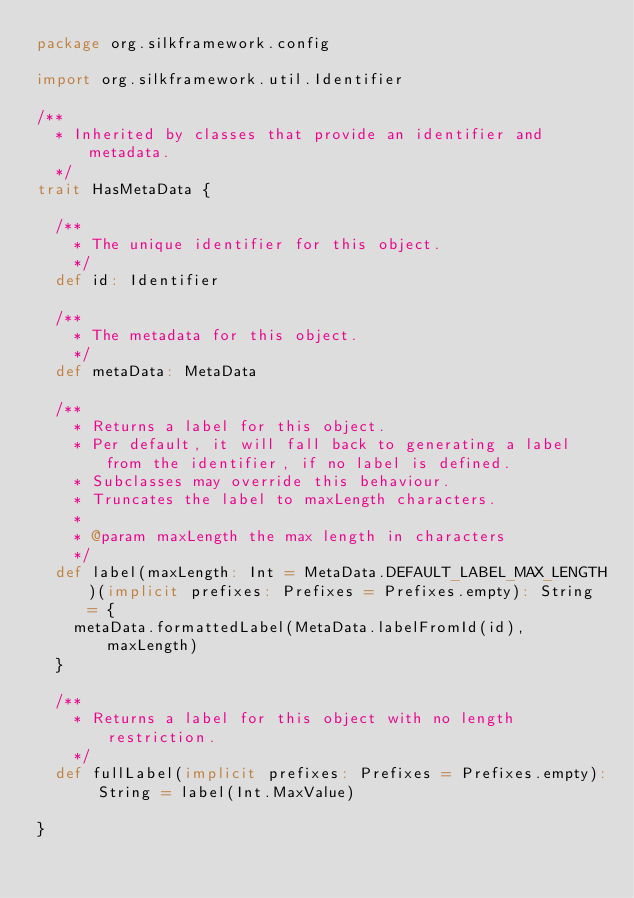Convert code to text. <code><loc_0><loc_0><loc_500><loc_500><_Scala_>package org.silkframework.config

import org.silkframework.util.Identifier

/**
  * Inherited by classes that provide an identifier and metadata.
  */
trait HasMetaData {

  /**
    * The unique identifier for this object.
    */
  def id: Identifier

  /**
    * The metadata for this object.
    */
  def metaData: MetaData

  /**
    * Returns a label for this object.
    * Per default, it will fall back to generating a label from the identifier, if no label is defined.
    * Subclasses may override this behaviour.
    * Truncates the label to maxLength characters.
    *
    * @param maxLength the max length in characters
    */
  def label(maxLength: Int = MetaData.DEFAULT_LABEL_MAX_LENGTH)(implicit prefixes: Prefixes = Prefixes.empty): String = {
    metaData.formattedLabel(MetaData.labelFromId(id), maxLength)
  }

  /**
    * Returns a label for this object with no length restriction.
    */
  def fullLabel(implicit prefixes: Prefixes = Prefixes.empty): String = label(Int.MaxValue)

}
</code> 